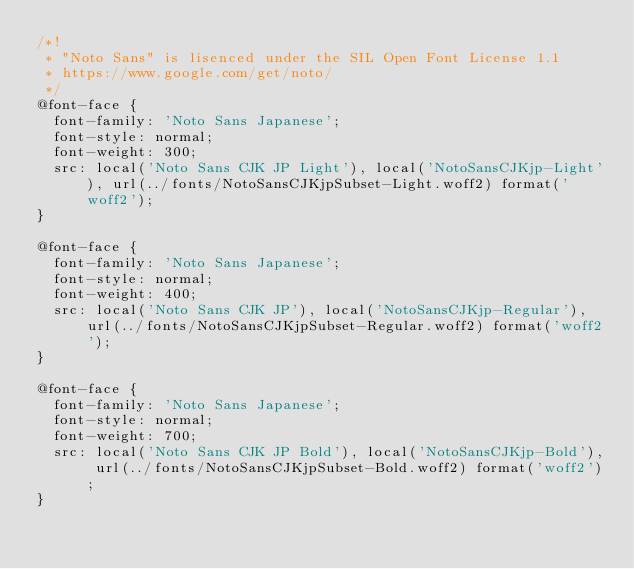<code> <loc_0><loc_0><loc_500><loc_500><_CSS_>/*!
 * "Noto Sans" is lisenced under the SIL Open Font License 1.1
 * https://www.google.com/get/noto/
 */
@font-face {
  font-family: 'Noto Sans Japanese';
  font-style: normal;
  font-weight: 300;
  src: local('Noto Sans CJK JP Light'), local('NotoSansCJKjp-Light'), url(../fonts/NotoSansCJKjpSubset-Light.woff2) format('woff2');
}

@font-face {
  font-family: 'Noto Sans Japanese';
  font-style: normal;
  font-weight: 400;
  src: local('Noto Sans CJK JP'), local('NotoSansCJKjp-Regular'), url(../fonts/NotoSansCJKjpSubset-Regular.woff2) format('woff2');
}

@font-face {
  font-family: 'Noto Sans Japanese';
  font-style: normal;
  font-weight: 700;
  src: local('Noto Sans CJK JP Bold'), local('NotoSansCJKjp-Bold'), url(../fonts/NotoSansCJKjpSubset-Bold.woff2) format('woff2');
}
</code> 